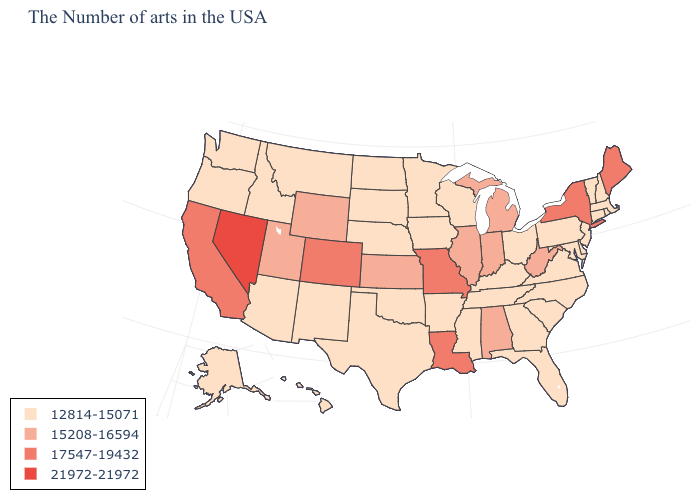Among the states that border South Carolina , which have the highest value?
Answer briefly. North Carolina, Georgia. Name the states that have a value in the range 17547-19432?
Be succinct. Maine, New York, Louisiana, Missouri, Colorado, California. What is the value of Louisiana?
Answer briefly. 17547-19432. Does the map have missing data?
Give a very brief answer. No. Among the states that border Tennessee , which have the highest value?
Write a very short answer. Missouri. What is the value of South Dakota?
Write a very short answer. 12814-15071. Does Utah have the lowest value in the West?
Be succinct. No. Does South Dakota have the lowest value in the MidWest?
Keep it brief. Yes. Does North Dakota have the lowest value in the MidWest?
Be succinct. Yes. Name the states that have a value in the range 12814-15071?
Keep it brief. Massachusetts, Rhode Island, New Hampshire, Vermont, Connecticut, New Jersey, Delaware, Maryland, Pennsylvania, Virginia, North Carolina, South Carolina, Ohio, Florida, Georgia, Kentucky, Tennessee, Wisconsin, Mississippi, Arkansas, Minnesota, Iowa, Nebraska, Oklahoma, Texas, South Dakota, North Dakota, New Mexico, Montana, Arizona, Idaho, Washington, Oregon, Alaska, Hawaii. Does Iowa have a lower value than Illinois?
Concise answer only. Yes. What is the value of Pennsylvania?
Give a very brief answer. 12814-15071. Which states have the lowest value in the MidWest?
Answer briefly. Ohio, Wisconsin, Minnesota, Iowa, Nebraska, South Dakota, North Dakota. Does Washington have the highest value in the West?
Give a very brief answer. No. Name the states that have a value in the range 21972-21972?
Answer briefly. Nevada. 